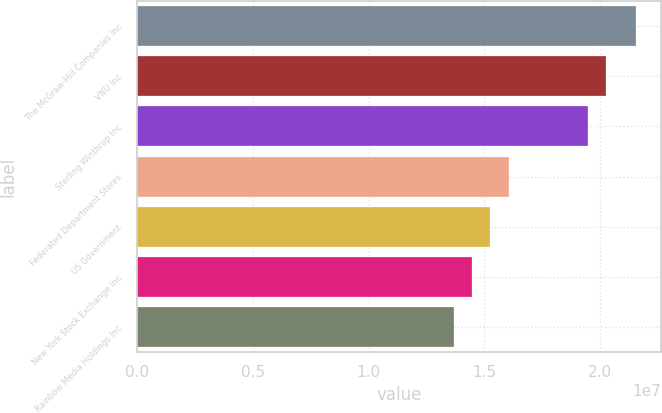Convert chart to OTSL. <chart><loc_0><loc_0><loc_500><loc_500><bar_chart><fcel>The McGraw-Hill Companies Inc<fcel>VNU Inc<fcel>Sterling Winthrop Inc<fcel>Federated Department Stores<fcel>US Government<fcel>New York Stock Exchange Inc<fcel>Rainbow Media Holdings Inc<nl><fcel>2.1541e+07<fcel>2.0264e+07<fcel>1.9479e+07<fcel>1.6046e+07<fcel>1.5261e+07<fcel>1.4476e+07<fcel>1.3691e+07<nl></chart> 